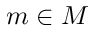Convert formula to latex. <formula><loc_0><loc_0><loc_500><loc_500>m \in M</formula> 